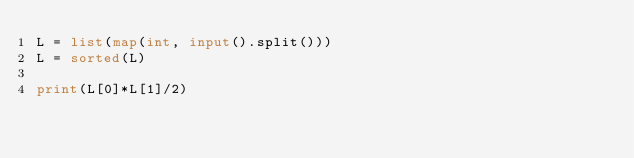Convert code to text. <code><loc_0><loc_0><loc_500><loc_500><_Python_>L = list(map(int, input().split()))
L = sorted(L)

print(L[0]*L[1]/2)</code> 